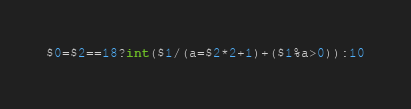Convert code to text. <code><loc_0><loc_0><loc_500><loc_500><_Awk_>$0=$2==18?int($1/(a=$2*2+1)+($1%a>0)):10</code> 